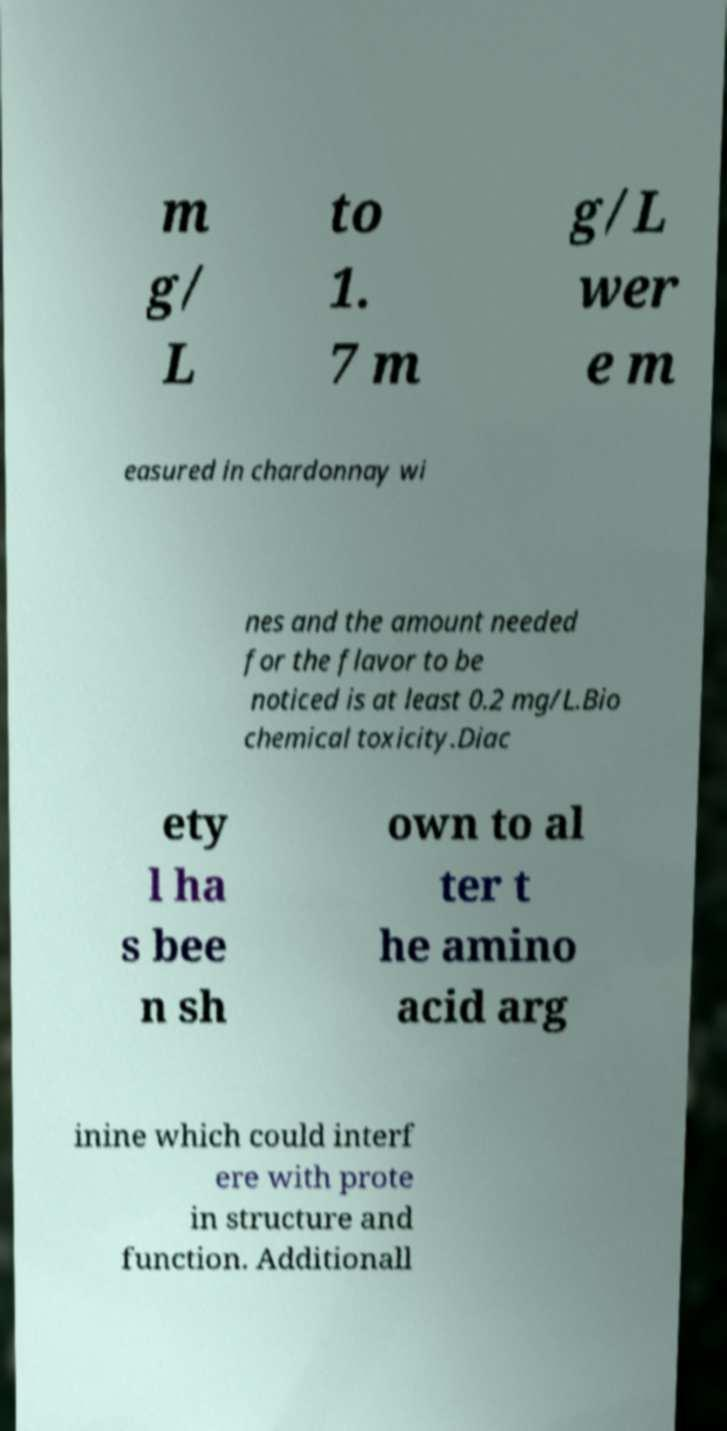I need the written content from this picture converted into text. Can you do that? m g/ L to 1. 7 m g/L wer e m easured in chardonnay wi nes and the amount needed for the flavor to be noticed is at least 0.2 mg/L.Bio chemical toxicity.Diac ety l ha s bee n sh own to al ter t he amino acid arg inine which could interf ere with prote in structure and function. Additionall 